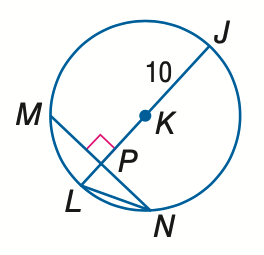Question: In \odot K, M N = 16 and m \widehat M N = 98. Find the measure of L N. Round to the nearest hundredth.
Choices:
A. 6.93
B. 7.50
C. 8.94
D. 10.00
Answer with the letter. Answer: C Question: In \odot K, M N = 16 and m \widehat M N = 98. Find the measure of m \widehat N J. Round to the nearest hundredth.
Choices:
A. 49.00
B. 82.00
C. 98.00
D. 131.00
Answer with the letter. Answer: D 